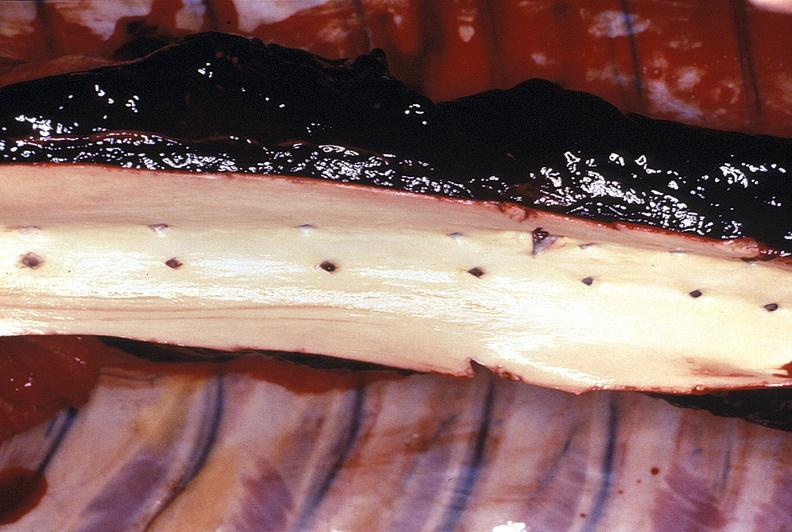what is present?
Answer the question using a single word or phrase. Vasculature 